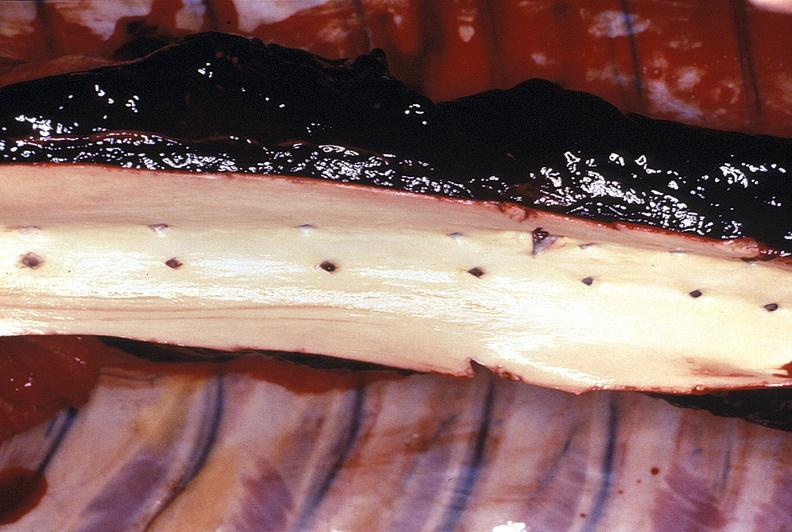what is present?
Answer the question using a single word or phrase. Vasculature 